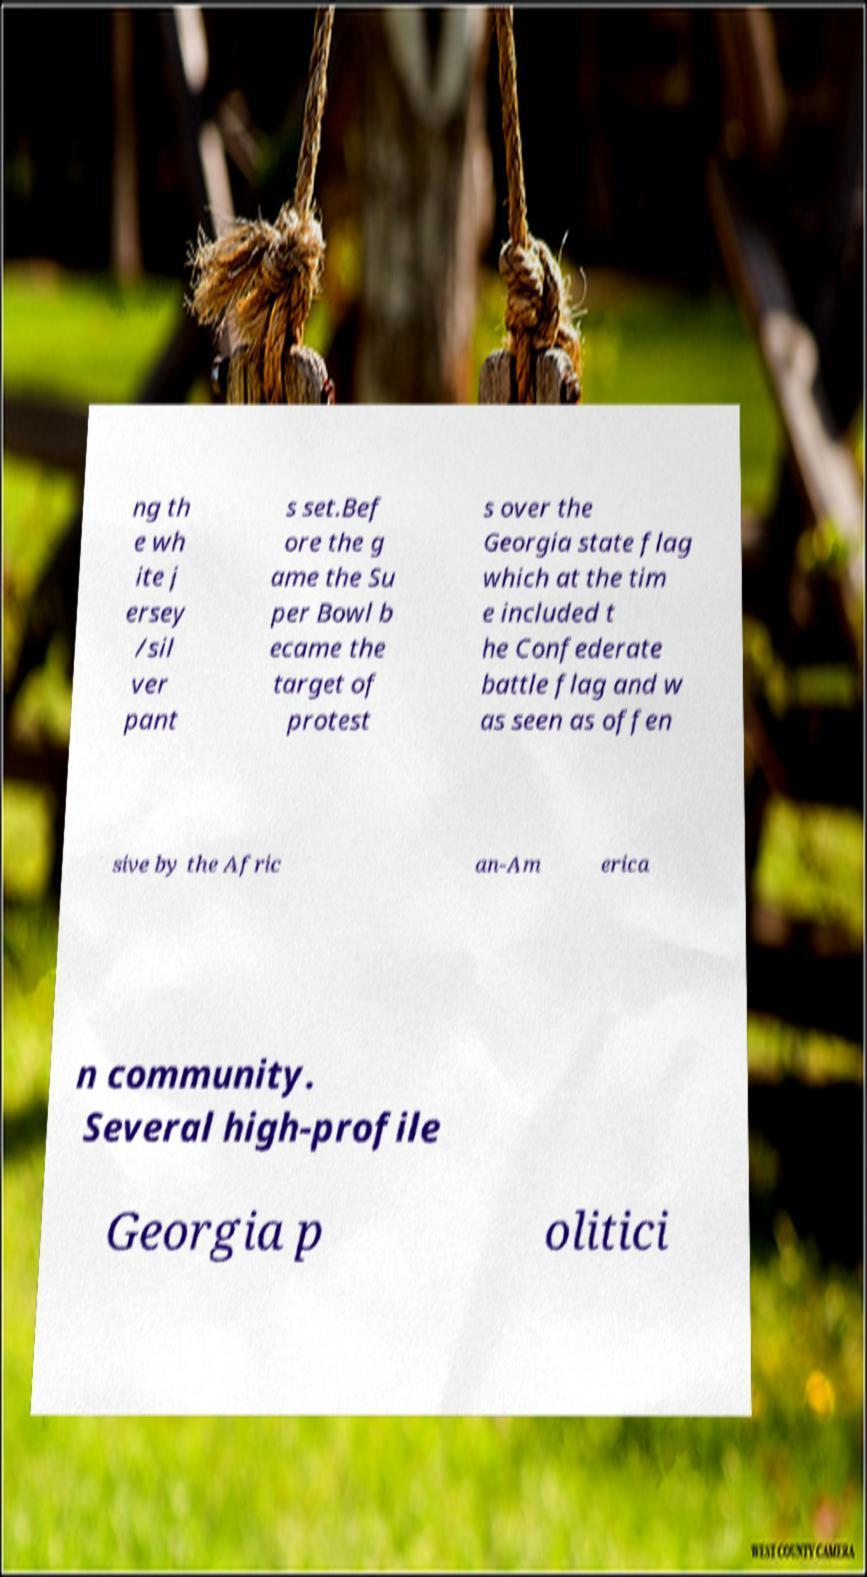I need the written content from this picture converted into text. Can you do that? ng th e wh ite j ersey /sil ver pant s set.Bef ore the g ame the Su per Bowl b ecame the target of protest s over the Georgia state flag which at the tim e included t he Confederate battle flag and w as seen as offen sive by the Afric an-Am erica n community. Several high-profile Georgia p olitici 